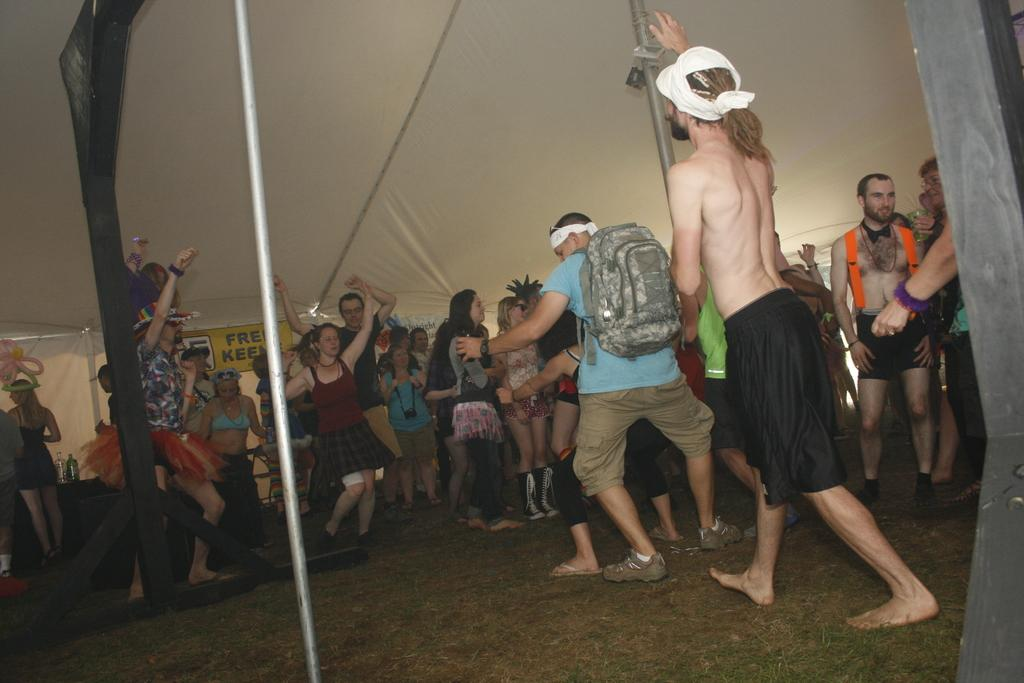What type of surface can be seen in the image? There is ground visible in the image. What are the people in the image doing? The people are standing under a tent. What color is the tent? The tent is cream in color. How many wooden poles are in the image? There are two wooden poles in the image. What type of pole is also present in the image? There is a metal pole in the image. What color is the board in the people might be looking at? There is a yellow-colored board in the image. What type of pollution is visible in the image? There is no visible pollution in the image. What religious symbol can be seen in the image? There is no religious symbol present in the image. 